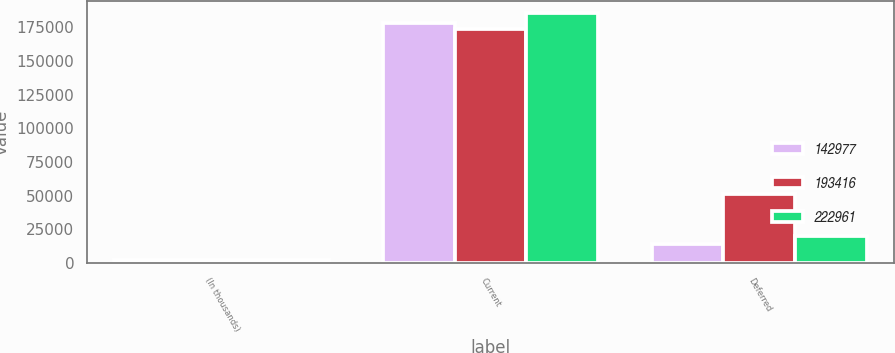Convert chart. <chart><loc_0><loc_0><loc_500><loc_500><stacked_bar_chart><ecel><fcel>(In thousands)<fcel>Current<fcel>Deferred<nl><fcel>142977<fcel>2014<fcel>178450<fcel>14277<nl><fcel>193416<fcel>2013<fcel>173418<fcel>51475<nl><fcel>222961<fcel>2012<fcel>185404<fcel>20086<nl></chart> 